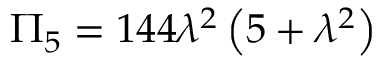Convert formula to latex. <formula><loc_0><loc_0><loc_500><loc_500>\Pi _ { 5 } = 1 4 4 \lambda ^ { 2 } \left ( 5 + \lambda ^ { 2 } \right )</formula> 